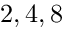<formula> <loc_0><loc_0><loc_500><loc_500>2 , 4 , 8</formula> 